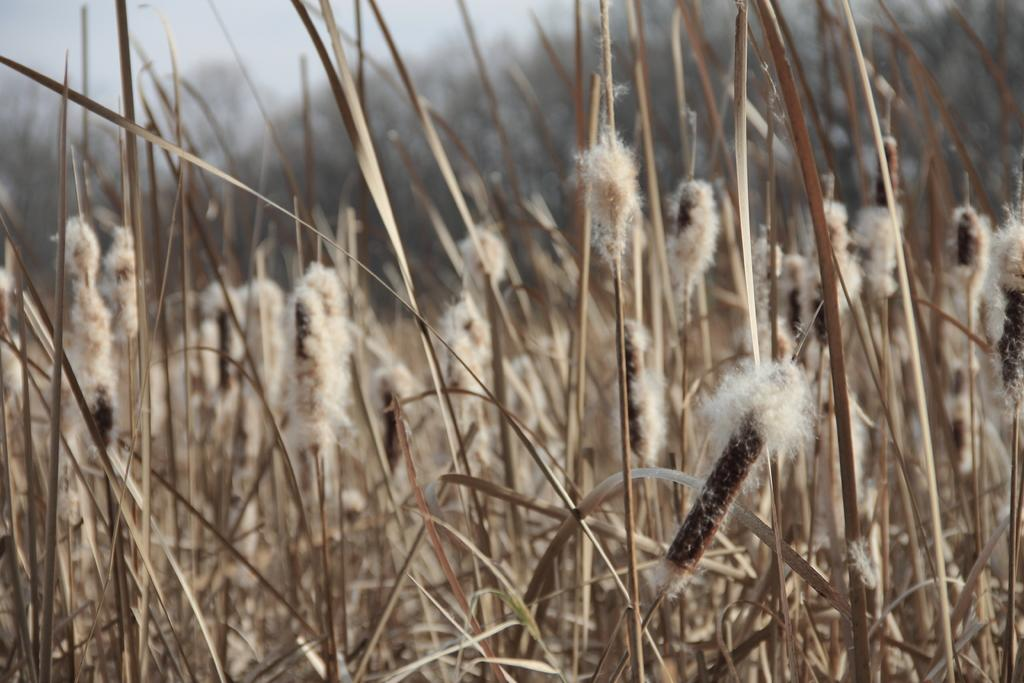What type of plants are in the image? There are cotton plants in the image. What is the color of the cotton plants? The cotton plants are in brown color. What part of the natural environment is visible in the image? The sky is visible in the image and is in white color. Where can the tomatoes be found in the image? There are no tomatoes present in the image. 